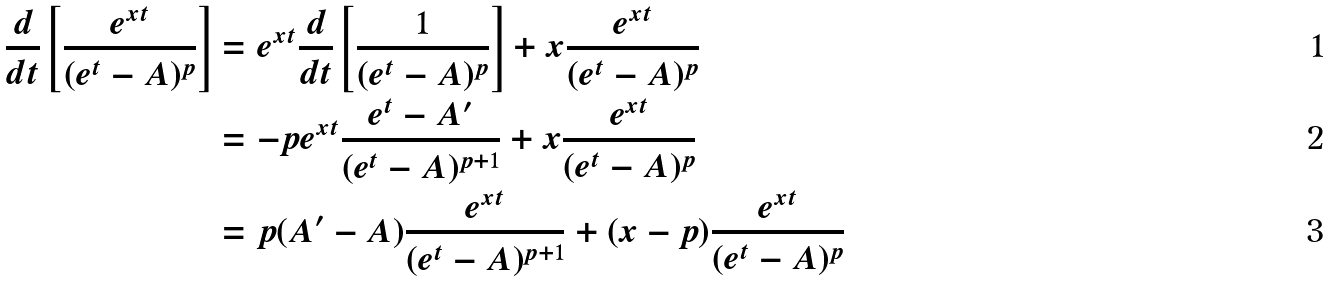<formula> <loc_0><loc_0><loc_500><loc_500>\frac { d } { d t } \left [ \frac { e ^ { x t } } { ( e ^ { t } - A ) ^ { p } } \right ] & = e ^ { x t } \frac { d } { d t } \left [ \frac { 1 } { ( e ^ { t } - A ) ^ { p } } \right ] + x \frac { e ^ { x t } } { ( e ^ { t } - A ) ^ { p } } \\ & = - p e ^ { x t } \frac { e ^ { t } - A ^ { \prime } } { ( e ^ { t } - A ) ^ { p + 1 } } + x \frac { e ^ { x t } } { ( e ^ { t } - A ) ^ { p } } \\ & = p ( A ^ { \prime } - A ) \frac { e ^ { x t } } { ( e ^ { t } - A ) ^ { p + 1 } } + ( x - p ) \frac { e ^ { x t } } { ( e ^ { t } - A ) ^ { p } }</formula> 